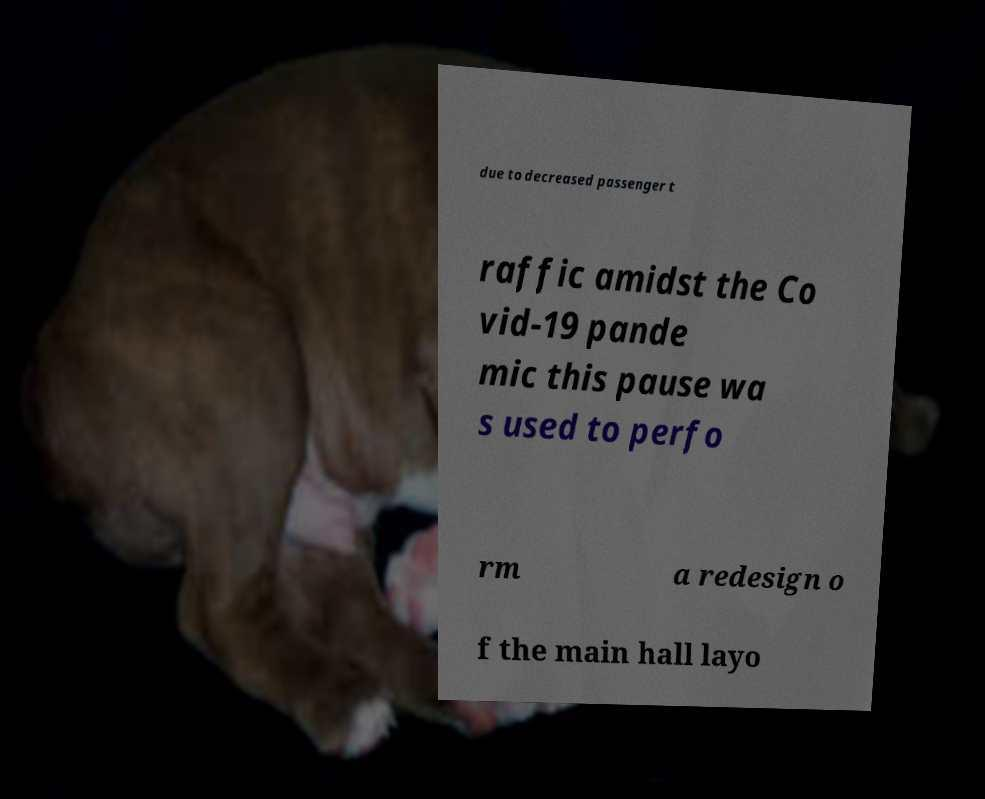What messages or text are displayed in this image? I need them in a readable, typed format. due to decreased passenger t raffic amidst the Co vid-19 pande mic this pause wa s used to perfo rm a redesign o f the main hall layo 